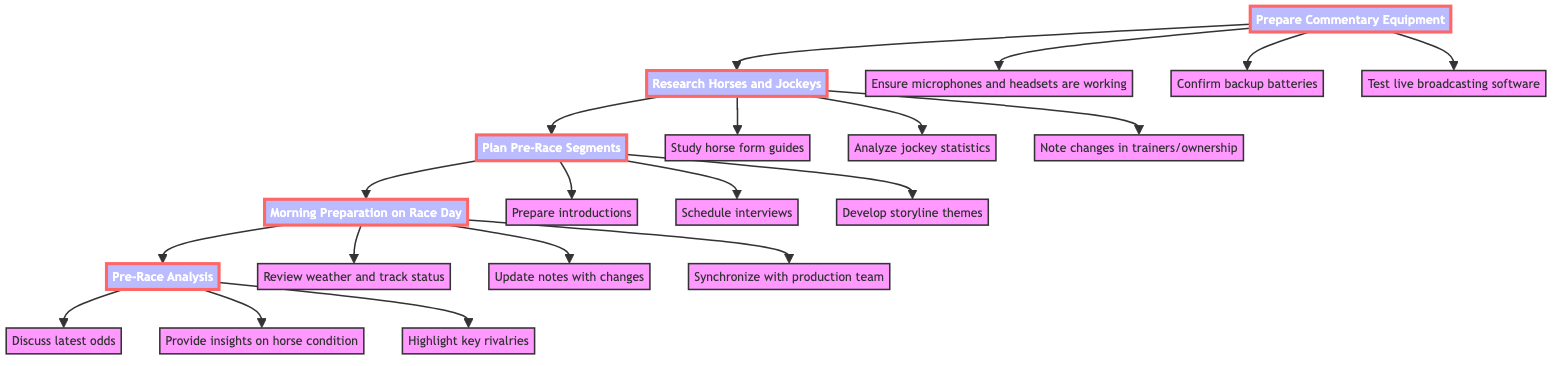What is the first step in the workflow? The first step in the workflow is indicated at the bottom of the flowchart and is labeled "Prepare Commentary Equipment."
Answer: Prepare Commentary Equipment How many main steps are there in the diagram? By counting the main flow chart nodes, we see there are five distinct steps shown in the flowchart: Prepare Commentary Equipment, Research Horses and Jockeys, Plan Pre-Race Segments, Morning Preparation on Race Day, and Pre-Race Analysis.
Answer: 5 What action corresponds to the step "Research Horses and Jockeys"? The "Research Horses and Jockeys" step has several specific actions listed as children nodes, one of which is "Study horse form guides and past performances."
Answer: Study horse form guides and past performances Which action relates to preparing for interviews? In the "Plan Pre-Race Segments" step, the action regarding preparing for interviews is to "Schedule interviews with trainers, jockeys, and owners."
Answer: Schedule interviews with trainers, jockeys, and owners What is the last step mentioned in the diagram? The final step in the workflow, located at the top of the diagram, is labeled "Pre-Race Analysis."
Answer: Pre-Race Analysis What type of information should be updated in the "Morning Preparation on Race Day"? During this step, it is important to "Update notes with any last-minute changes or scratches," indicating the need for timely information.
Answer: Update notes with any last-minute changes or scratches How does "Morning Preparation on Race Day" lead into "Pre-Race Analysis"? The diagram shows a direct flow connection from "Morning Preparation on Race Day" to "Pre-Race Analysis," indicating a progression of tasks from day-of activities to final analysis.
Answer: Direct flow connection What are the actions under the "Prepare Commentary Equipment" step? The actions listed under this step float down from the main node and include "Ensure microphones and headsets are in working order," "Confirm backup batteries are on hand," and "Test live broadcasting software."
Answer: Ensure microphones and headsets are in working order, Confirm backup batteries are on hand, Test live broadcasting software What does "Pre-Race Analysis" highlight according to the workflow? The workflow indicates that "Pre-Race Analysis" highlights "key rivalries and potential outcomes," focusing on strategic aspects of the race.
Answer: Highlight key rivalries and potential outcomes 